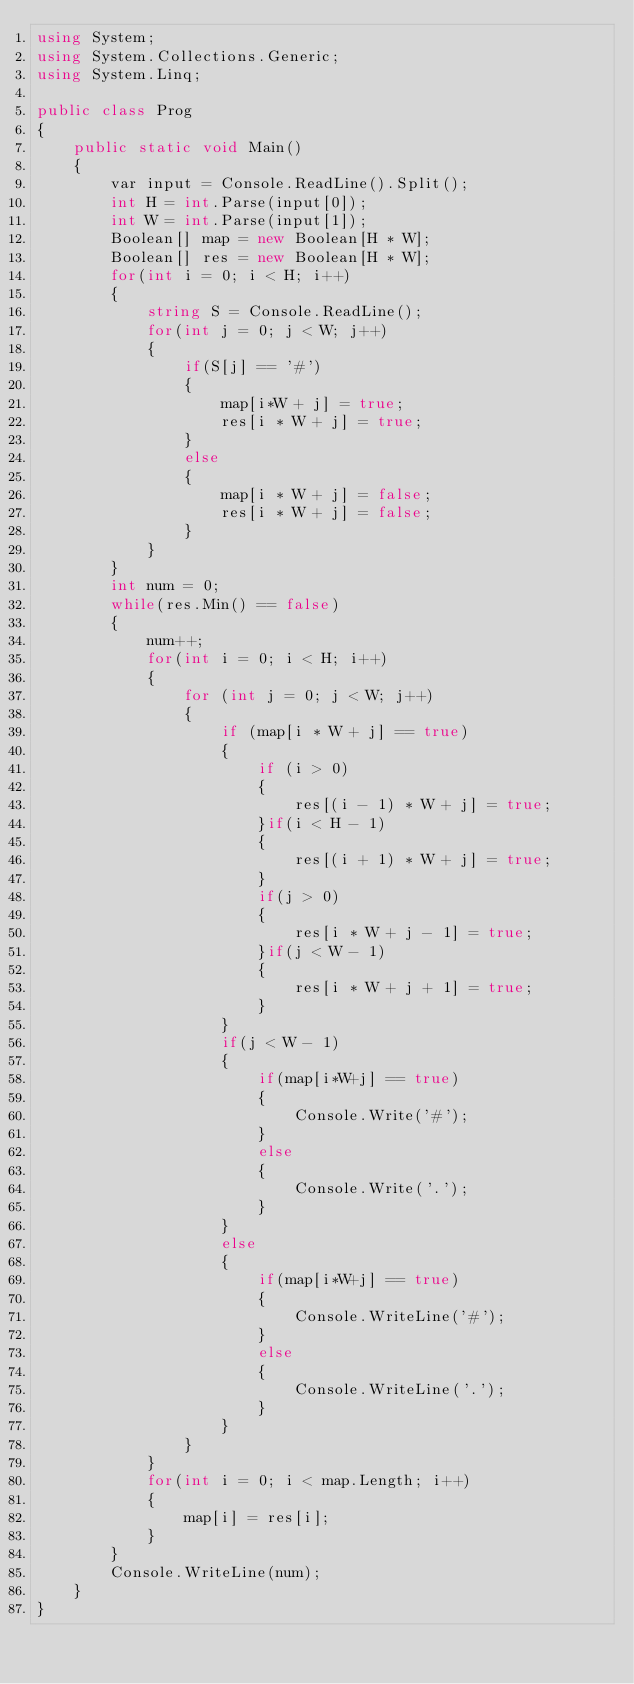Convert code to text. <code><loc_0><loc_0><loc_500><loc_500><_C#_>using System;
using System.Collections.Generic;
using System.Linq;

public class Prog
{
    public static void Main()
    {
        var input = Console.ReadLine().Split();
        int H = int.Parse(input[0]);
        int W = int.Parse(input[1]);
        Boolean[] map = new Boolean[H * W];
        Boolean[] res = new Boolean[H * W];
        for(int i = 0; i < H; i++)
        {
            string S = Console.ReadLine();
            for(int j = 0; j < W; j++)
            {
                if(S[j] == '#')
                {
                    map[i*W + j] = true;
                    res[i * W + j] = true;
                }
                else
                {
                    map[i * W + j] = false;
                    res[i * W + j] = false;
                }
            }
        }
        int num = 0;
        while(res.Min() == false)
        {
            num++;
            for(int i = 0; i < H; i++)
            {
                for (int j = 0; j < W; j++)
                {
                    if (map[i * W + j] == true)
                    {
                        if (i > 0)
                        {
                            res[(i - 1) * W + j] = true;
                        }if(i < H - 1)
                        {
                            res[(i + 1) * W + j] = true;
                        }
                        if(j > 0)
                        {
                            res[i * W + j - 1] = true;
                        }if(j < W - 1)
                        {
                            res[i * W + j + 1] = true;
                        }
                    }
                    if(j < W - 1)
                    {
                        if(map[i*W+j] == true)
                        {
                            Console.Write('#');
                        }
                        else
                        {
                            Console.Write('.');
                        }
                    }
                    else
                    {
                        if(map[i*W+j] == true)
                        {
                            Console.WriteLine('#');
                        }
                        else
                        {
                            Console.WriteLine('.');
                        }
                    }
                }
            }
            for(int i = 0; i < map.Length; i++)
            {
                map[i] = res[i];
            }
        }
        Console.WriteLine(num);
    }
}

</code> 